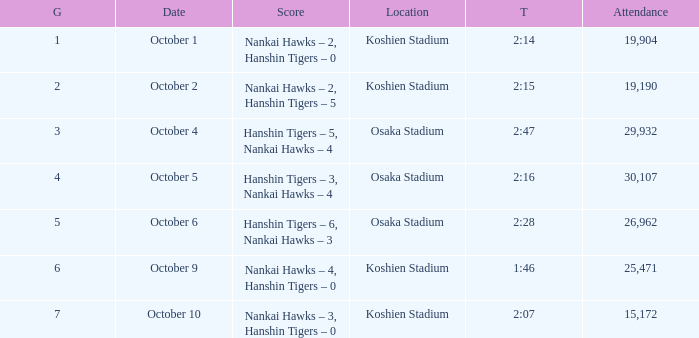Which score holds a duration of 2:28? Hanshin Tigers – 6, Nankai Hawks – 3. 